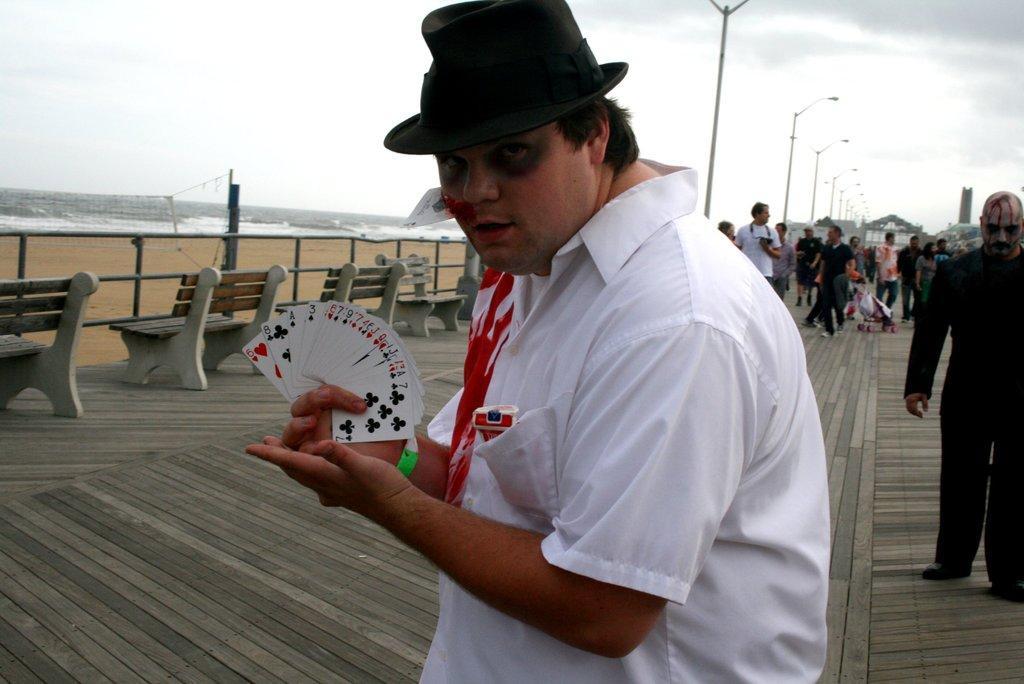Could you give a brief overview of what you see in this image? In this image we can see a person in the middle of the image holding some playing cards and posing for a photo and to the right side we can see some people. We can see some benches and street lights on the surface and on the left side, we can see the sea shore. 